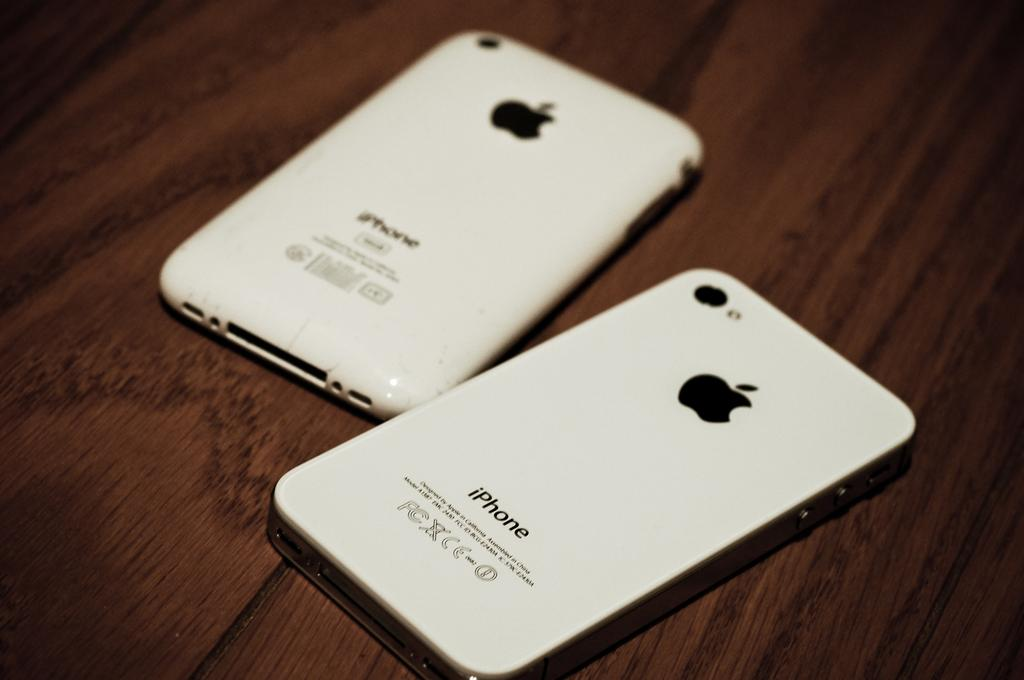<image>
Create a compact narrative representing the image presented. Two white iphones laid down on a table with back screen showing 